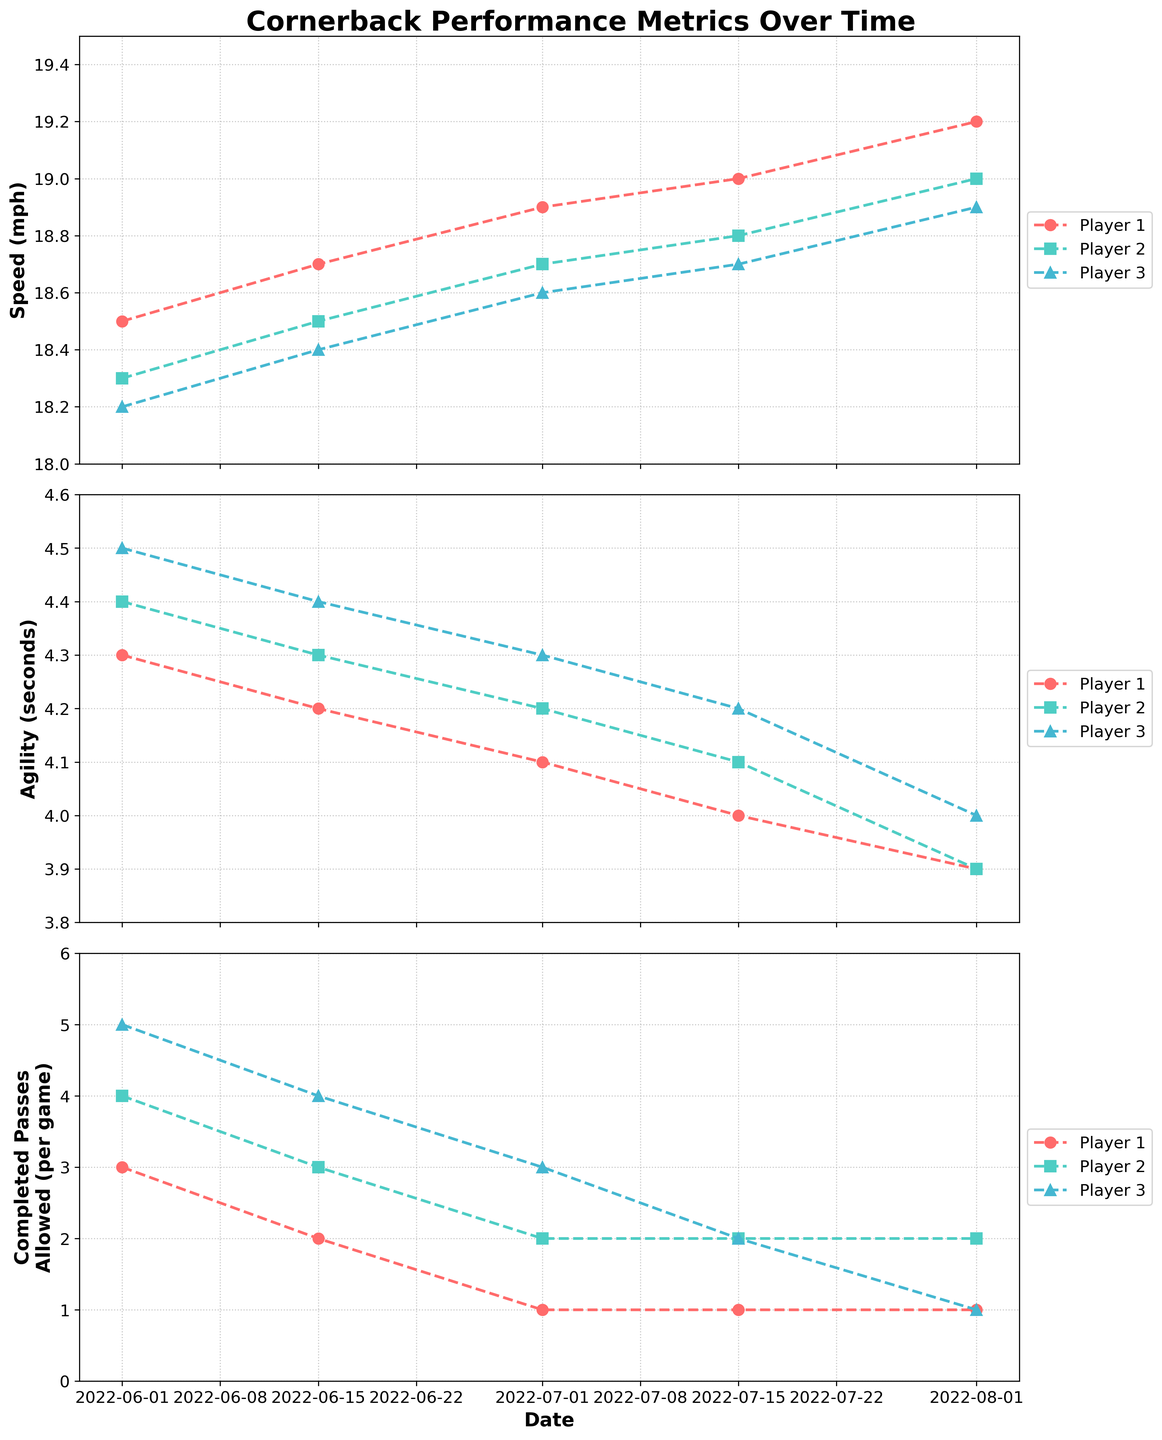What is the title of the figure? The title is found at the top center of the figure in a bold and large font size.
Answer: Cornerback Performance Metrics Over Time What is the highest speed recorded by Player 1 and when was it recorded? Look at the Speed (mph) plot for Player 1 (identified by its unique color and marker shape) and find the maximum data point value and its corresponding date.
Answer: 19.2 mph on 2022-08-01 Which player showed the most improvement in agility from the start to the end of the period? Compare the change in values in the Agility (seconds) plot for each player from the first to the last data point. Player with the greatest decrease in agility time has the most improvement.
Answer: Player 3 On what date did Player 2 first record a speed of at least 18.7 mph? Check Player 2’s Speed (mph) line and find the earliest date where the speed meets or exceeds 18.7 mph.
Answer: 2022-07-01 How many data points are plotted for each player? Count the number of markers (data points) for any player in one of the plots. They should be consistent across all three plots.
Answer: 5 Which player has allowed the fewest completed passes per game in August? Look at the Completed Passes Allowed plot for the month of August and identify the player with the lowest value.
Answer: Player 1 and Player 3 tied How much did Player 1's speed increase from the first to the last recorded date? Subtract Player 1's speed on the first date (June 1) from the speed on the last date (August 1).
Answer: 0.7 mph Which player showed the most consistent performance in terms of agility? Evaluate the Agility (seconds) plot for each player. The player with the least variation between data points shows the most consistent performance.
Answer: Player 2 What is the range of the agility times recorded over the period for Player 3? Identify the highest and lowest agility times in the Player 3 data and calculate the difference.
Answer: 4.5 - 4.0 = 0.5 seconds 